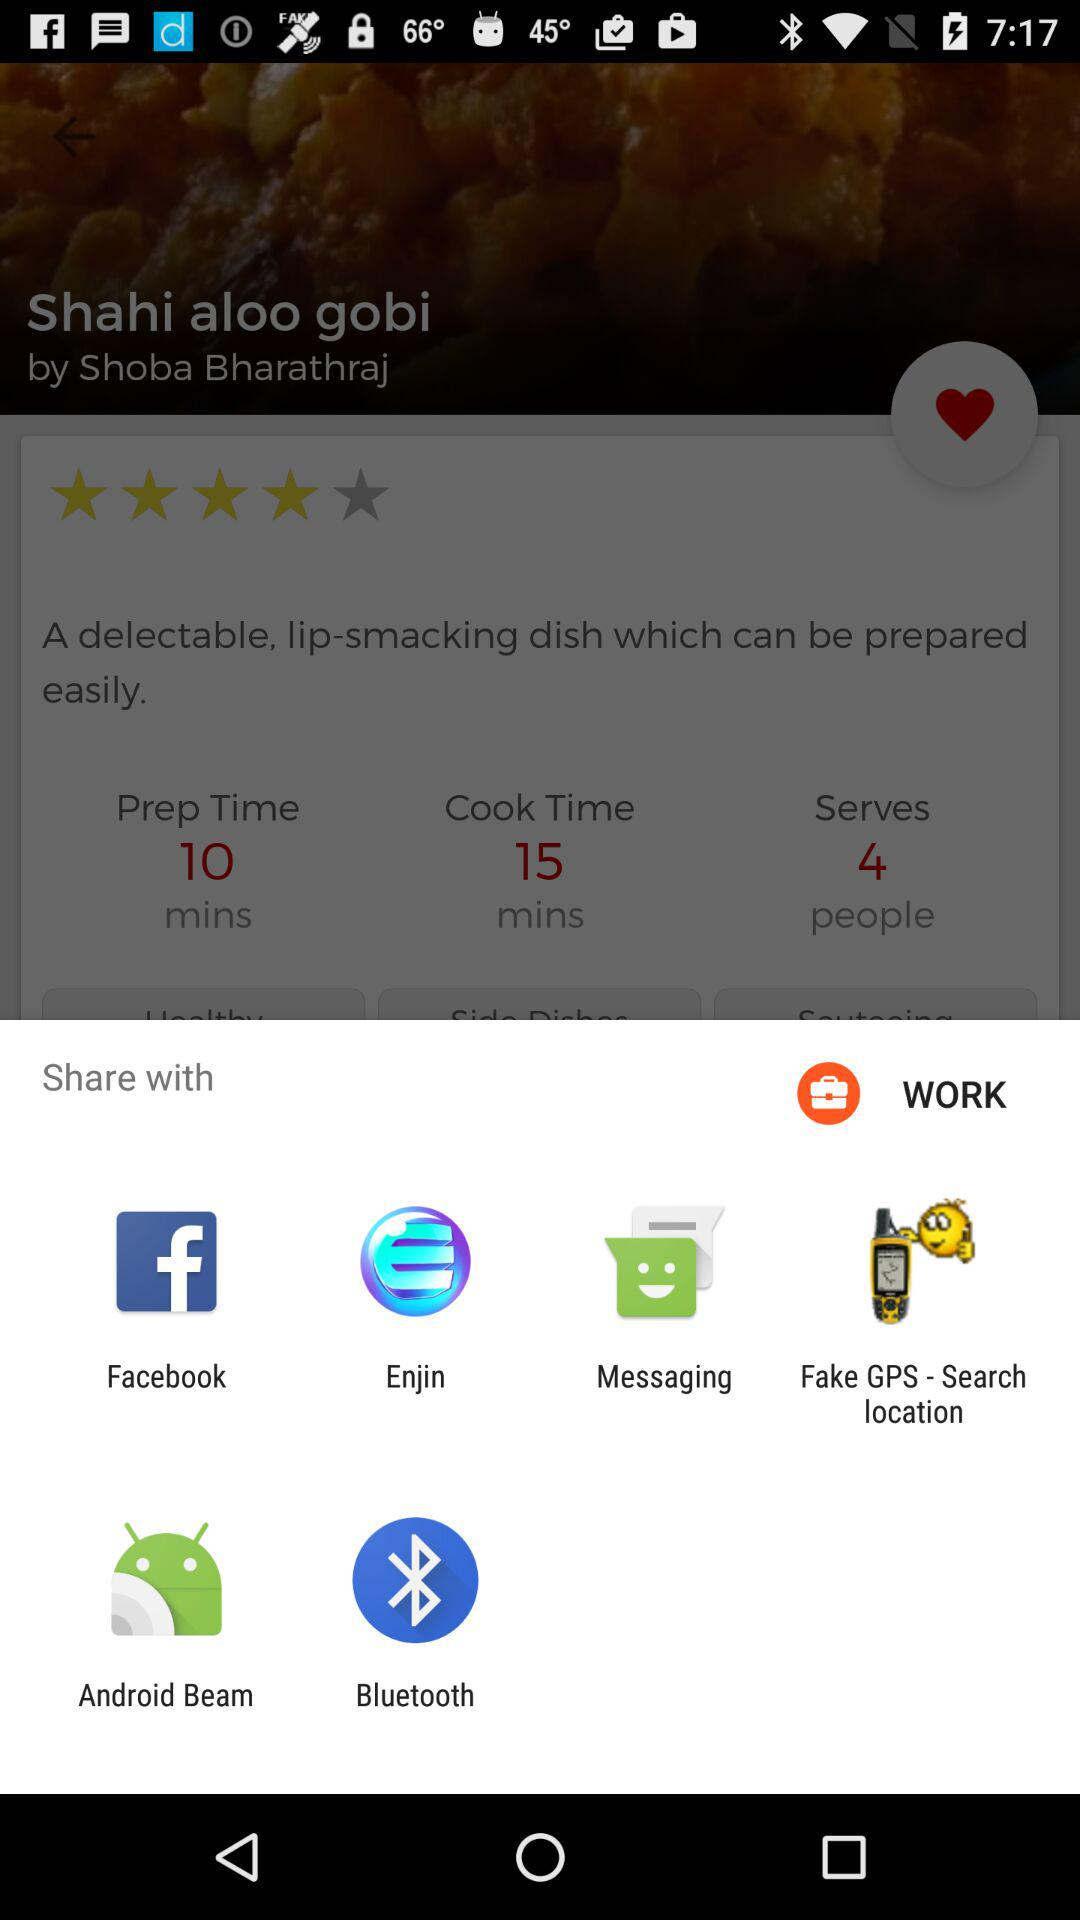How many more minutes is the cook time than the prep time?
Answer the question using a single word or phrase. 5 